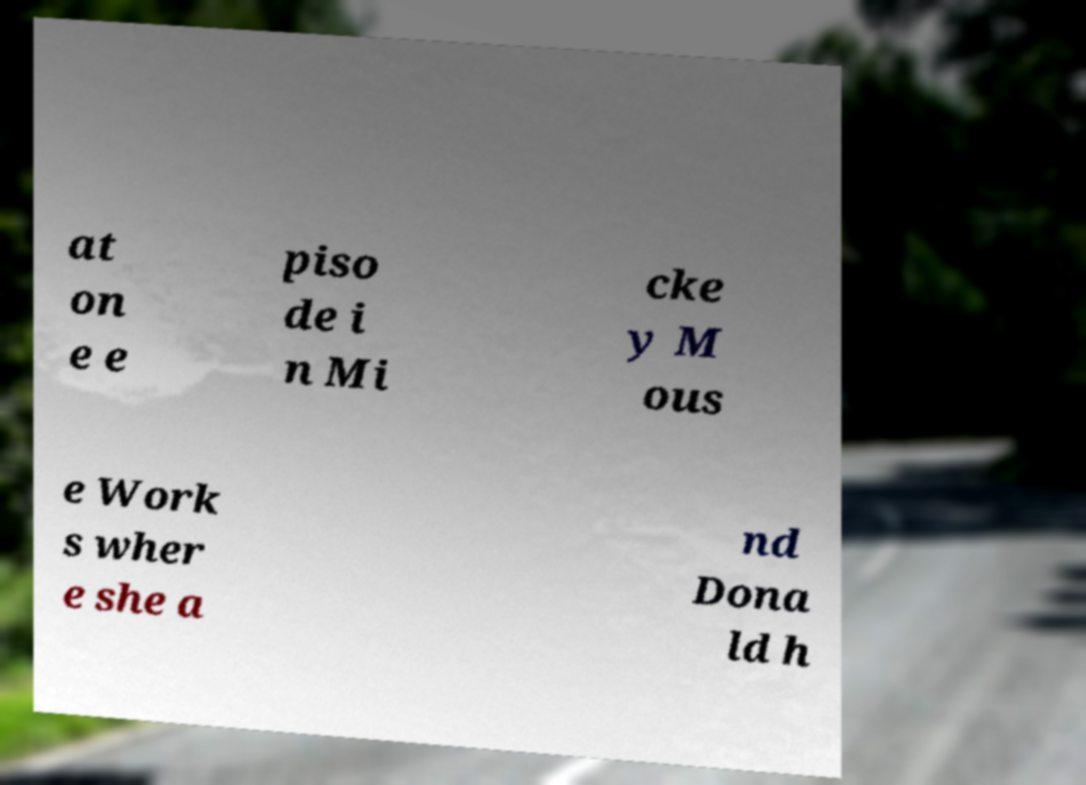What messages or text are displayed in this image? I need them in a readable, typed format. at on e e piso de i n Mi cke y M ous e Work s wher e she a nd Dona ld h 